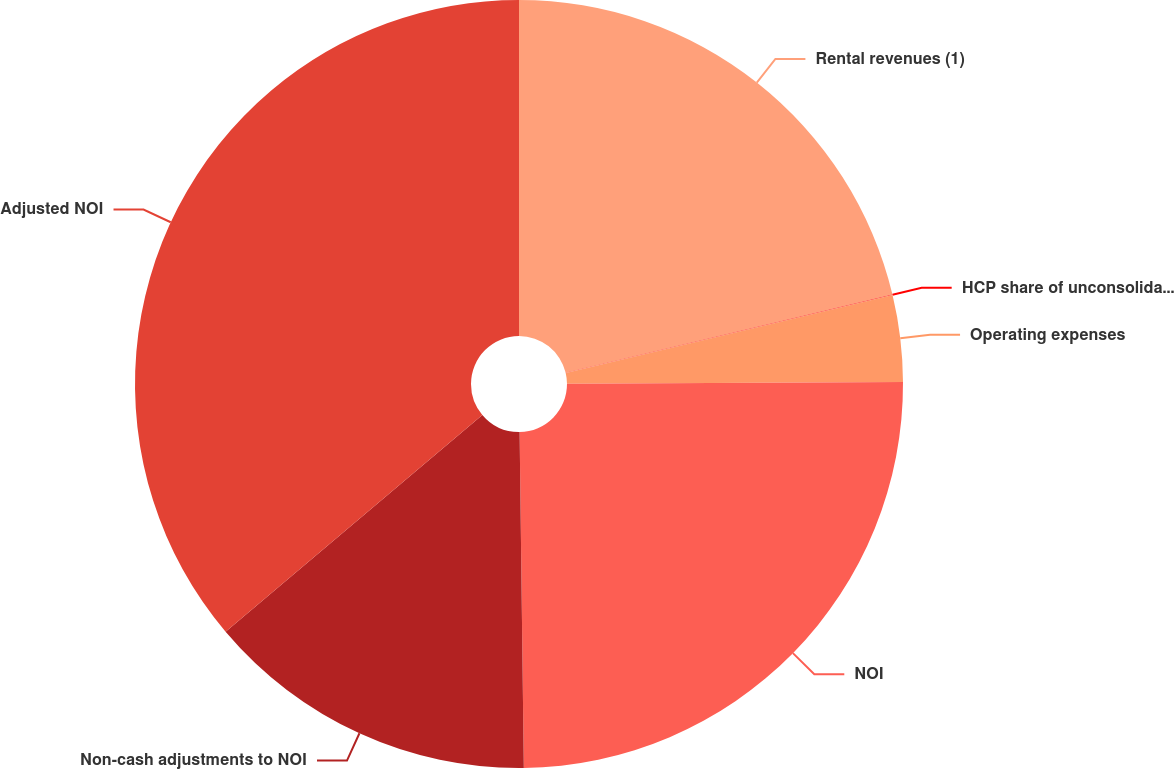<chart> <loc_0><loc_0><loc_500><loc_500><pie_chart><fcel>Rental revenues (1)<fcel>HCP share of unconsolidated JV<fcel>Operating expenses<fcel>NOI<fcel>Non-cash adjustments to NOI<fcel>Adjusted NOI<nl><fcel>21.26%<fcel>0.02%<fcel>3.64%<fcel>24.88%<fcel>14.04%<fcel>36.16%<nl></chart> 